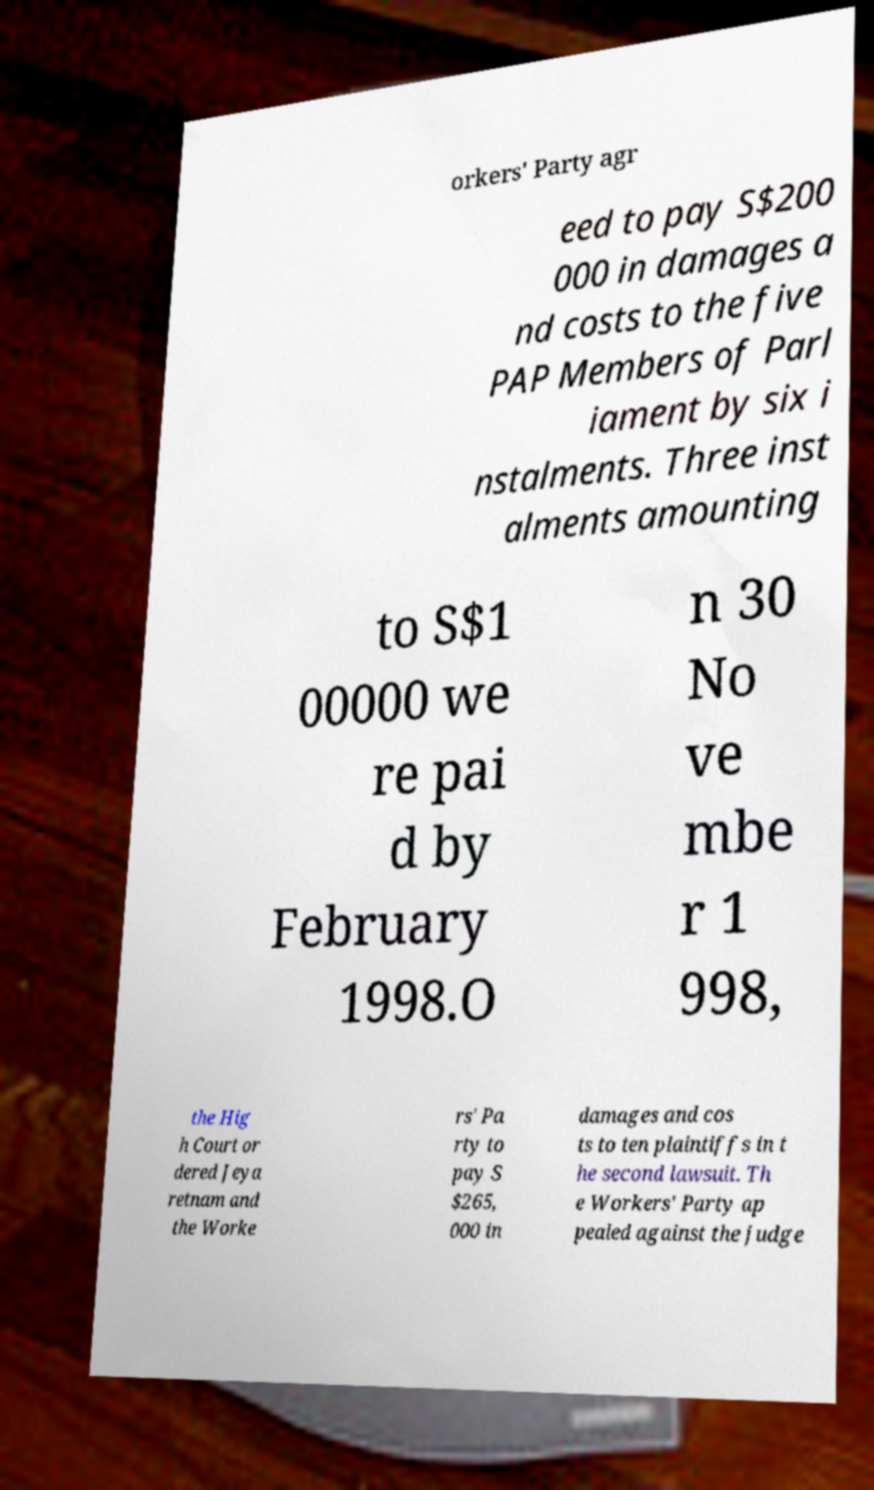I need the written content from this picture converted into text. Can you do that? orkers' Party agr eed to pay S$200 000 in damages a nd costs to the five PAP Members of Parl iament by six i nstalments. Three inst alments amounting to S$1 00000 we re pai d by February 1998.O n 30 No ve mbe r 1 998, the Hig h Court or dered Jeya retnam and the Worke rs' Pa rty to pay S $265, 000 in damages and cos ts to ten plaintiffs in t he second lawsuit. Th e Workers' Party ap pealed against the judge 